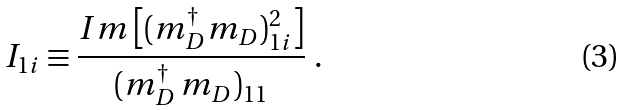<formula> <loc_0><loc_0><loc_500><loc_500>I _ { 1 i } \equiv \frac { I m \left [ ( m _ { D } ^ { \dagger } m _ { D } ) _ { 1 i } ^ { 2 } \right ] } { ( m _ { D } ^ { \dagger } \, m _ { D } ) _ { 1 1 } } \ .</formula> 